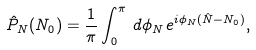<formula> <loc_0><loc_0><loc_500><loc_500>\hat { P } _ { N } ( N _ { 0 } ) = \frac { 1 } { \pi } \int _ { 0 } ^ { \pi } \, d \phi _ { N } \, e ^ { i \phi _ { N } ( \hat { N } - N _ { 0 } ) } ,</formula> 